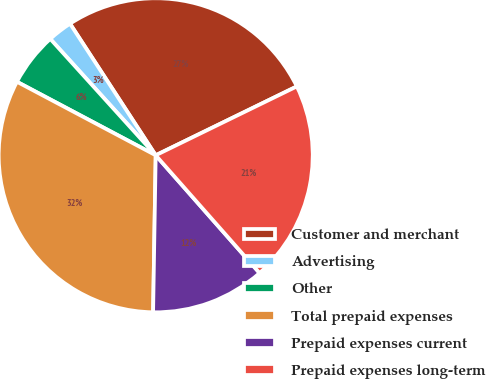Convert chart. <chart><loc_0><loc_0><loc_500><loc_500><pie_chart><fcel>Customer and merchant<fcel>Advertising<fcel>Other<fcel>Total prepaid expenses<fcel>Prepaid expenses current<fcel>Prepaid expenses long-term<nl><fcel>26.96%<fcel>2.53%<fcel>5.53%<fcel>32.49%<fcel>11.77%<fcel>20.72%<nl></chart> 